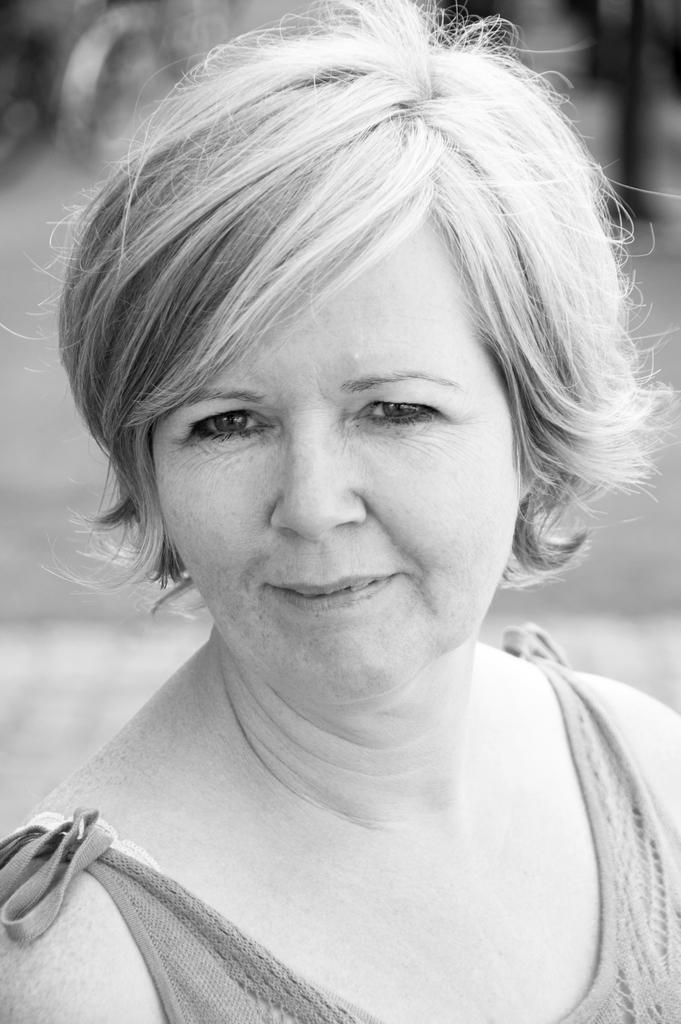What is the color scheme of the image? The image is black and white. Can you describe the person in the image? There is a woman in the image. What expression does the woman have on her face? The woman has a smiling face. What type of grape is the woman holding in the image? There is no grape present in the image; it is a black and white image of a woman with a smiling face. 